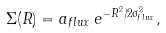<formula> <loc_0><loc_0><loc_500><loc_500>\Sigma ( R ) = a _ { f l u x } \, e ^ { - R ^ { 2 } / 2 \sigma ^ { 2 } _ { f l u x } } ,</formula> 